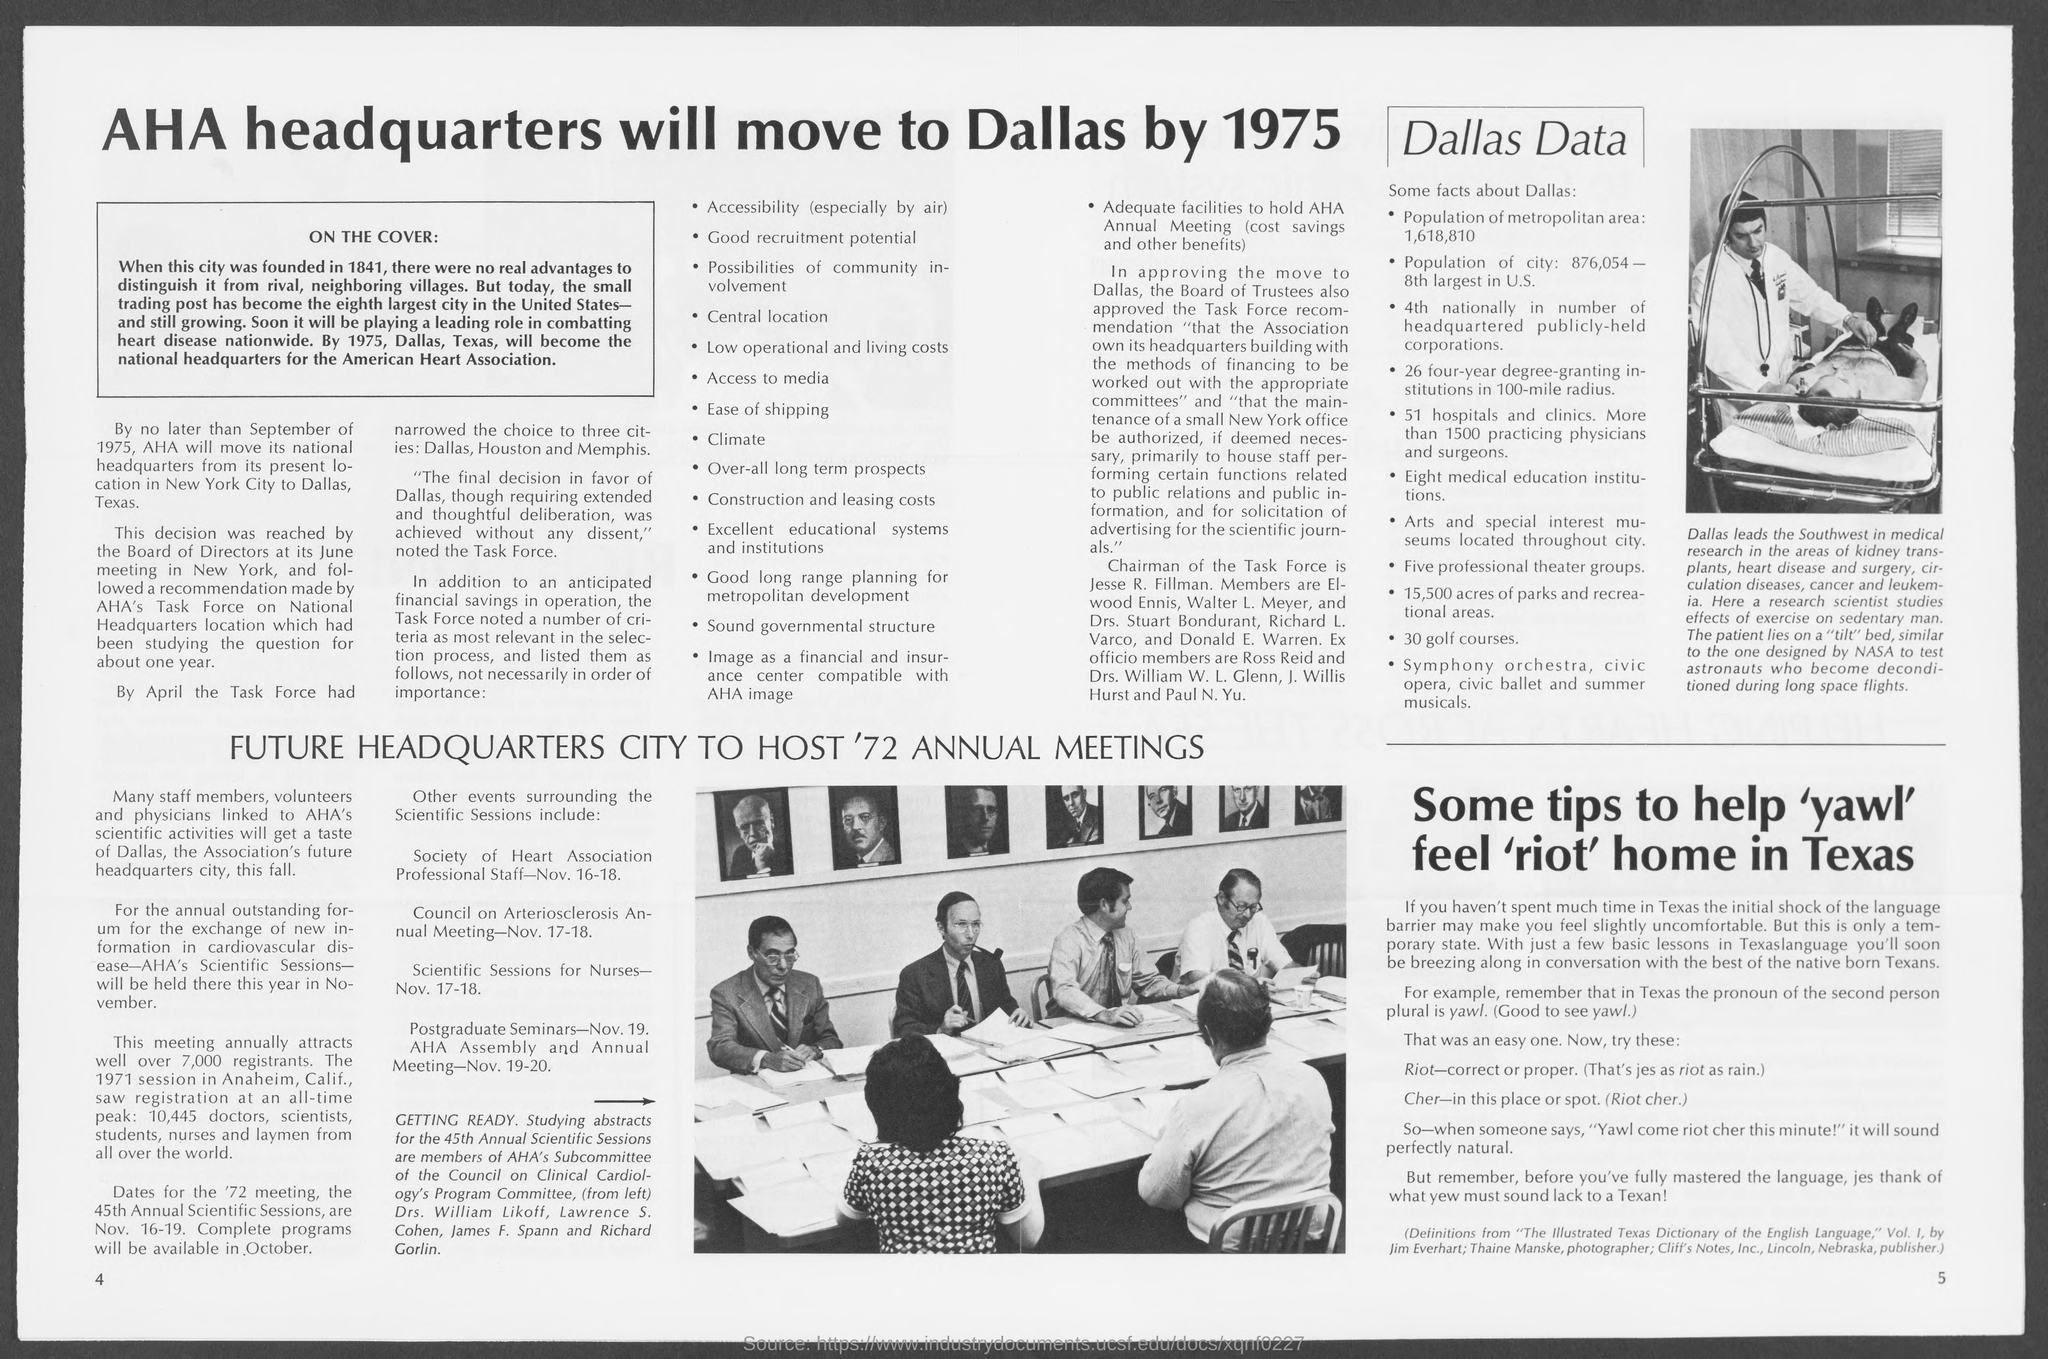What is the number at bottom left page ?
Keep it short and to the point. 4. What is the number at bottom right page?
Keep it short and to the point. 5. 